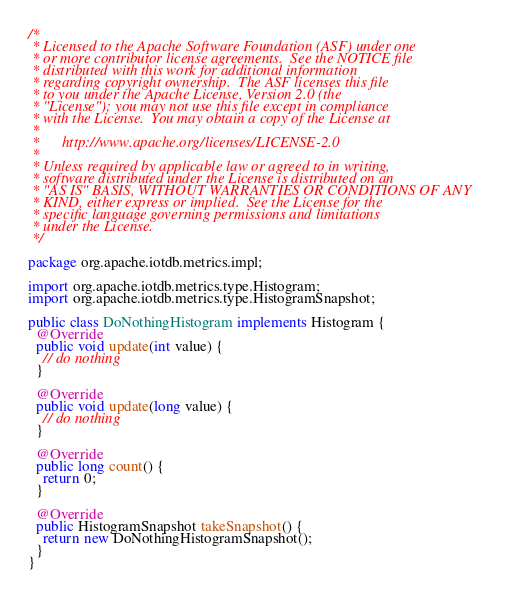Convert code to text. <code><loc_0><loc_0><loc_500><loc_500><_Java_>/*
 * Licensed to the Apache Software Foundation (ASF) under one
 * or more contributor license agreements.  See the NOTICE file
 * distributed with this work for additional information
 * regarding copyright ownership.  The ASF licenses this file
 * to you under the Apache License, Version 2.0 (the
 * "License"); you may not use this file except in compliance
 * with the License.  You may obtain a copy of the License at
 *
 *      http://www.apache.org/licenses/LICENSE-2.0
 *
 * Unless required by applicable law or agreed to in writing,
 * software distributed under the License is distributed on an
 * "AS IS" BASIS, WITHOUT WARRANTIES OR CONDITIONS OF ANY
 * KIND, either express or implied.  See the License for the
 * specific language governing permissions and limitations
 * under the License.
 */

package org.apache.iotdb.metrics.impl;

import org.apache.iotdb.metrics.type.Histogram;
import org.apache.iotdb.metrics.type.HistogramSnapshot;

public class DoNothingHistogram implements Histogram {
  @Override
  public void update(int value) {
    // do nothing
  }

  @Override
  public void update(long value) {
    // do nothing
  }

  @Override
  public long count() {
    return 0;
  }

  @Override
  public HistogramSnapshot takeSnapshot() {
    return new DoNothingHistogramSnapshot();
  }
}
</code> 